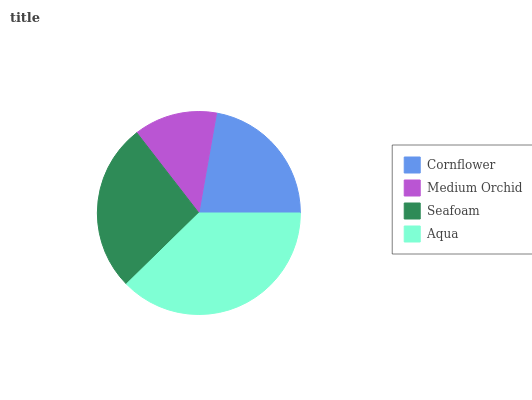Is Medium Orchid the minimum?
Answer yes or no. Yes. Is Aqua the maximum?
Answer yes or no. Yes. Is Seafoam the minimum?
Answer yes or no. No. Is Seafoam the maximum?
Answer yes or no. No. Is Seafoam greater than Medium Orchid?
Answer yes or no. Yes. Is Medium Orchid less than Seafoam?
Answer yes or no. Yes. Is Medium Orchid greater than Seafoam?
Answer yes or no. No. Is Seafoam less than Medium Orchid?
Answer yes or no. No. Is Seafoam the high median?
Answer yes or no. Yes. Is Cornflower the low median?
Answer yes or no. Yes. Is Medium Orchid the high median?
Answer yes or no. No. Is Aqua the low median?
Answer yes or no. No. 